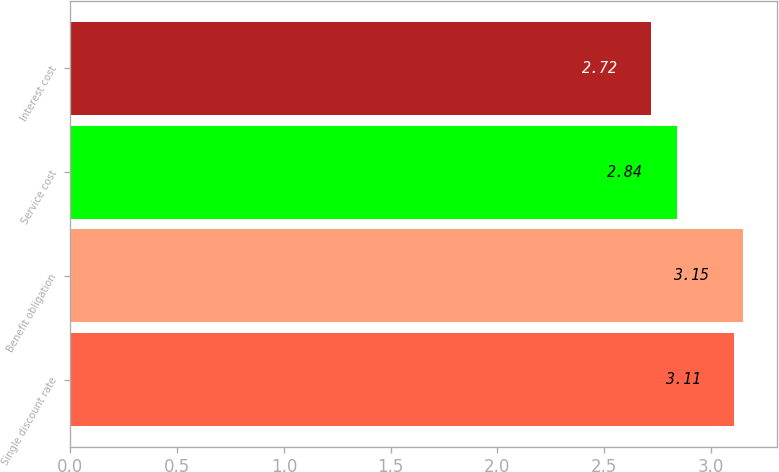Convert chart. <chart><loc_0><loc_0><loc_500><loc_500><bar_chart><fcel>Single discount rate<fcel>Benefit obligation<fcel>Service cost<fcel>Interest cost<nl><fcel>3.11<fcel>3.15<fcel>2.84<fcel>2.72<nl></chart> 